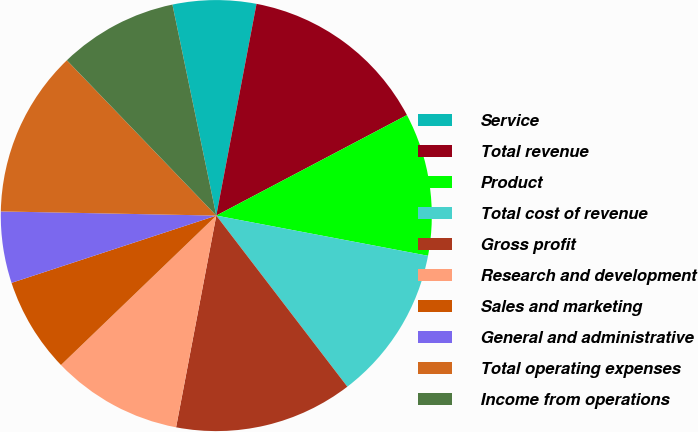Convert chart. <chart><loc_0><loc_0><loc_500><loc_500><pie_chart><fcel>Service<fcel>Total revenue<fcel>Product<fcel>Total cost of revenue<fcel>Gross profit<fcel>Research and development<fcel>Sales and marketing<fcel>General and administrative<fcel>Total operating expenses<fcel>Income from operations<nl><fcel>6.25%<fcel>14.29%<fcel>10.71%<fcel>11.61%<fcel>13.39%<fcel>9.82%<fcel>7.14%<fcel>5.36%<fcel>12.5%<fcel>8.93%<nl></chart> 